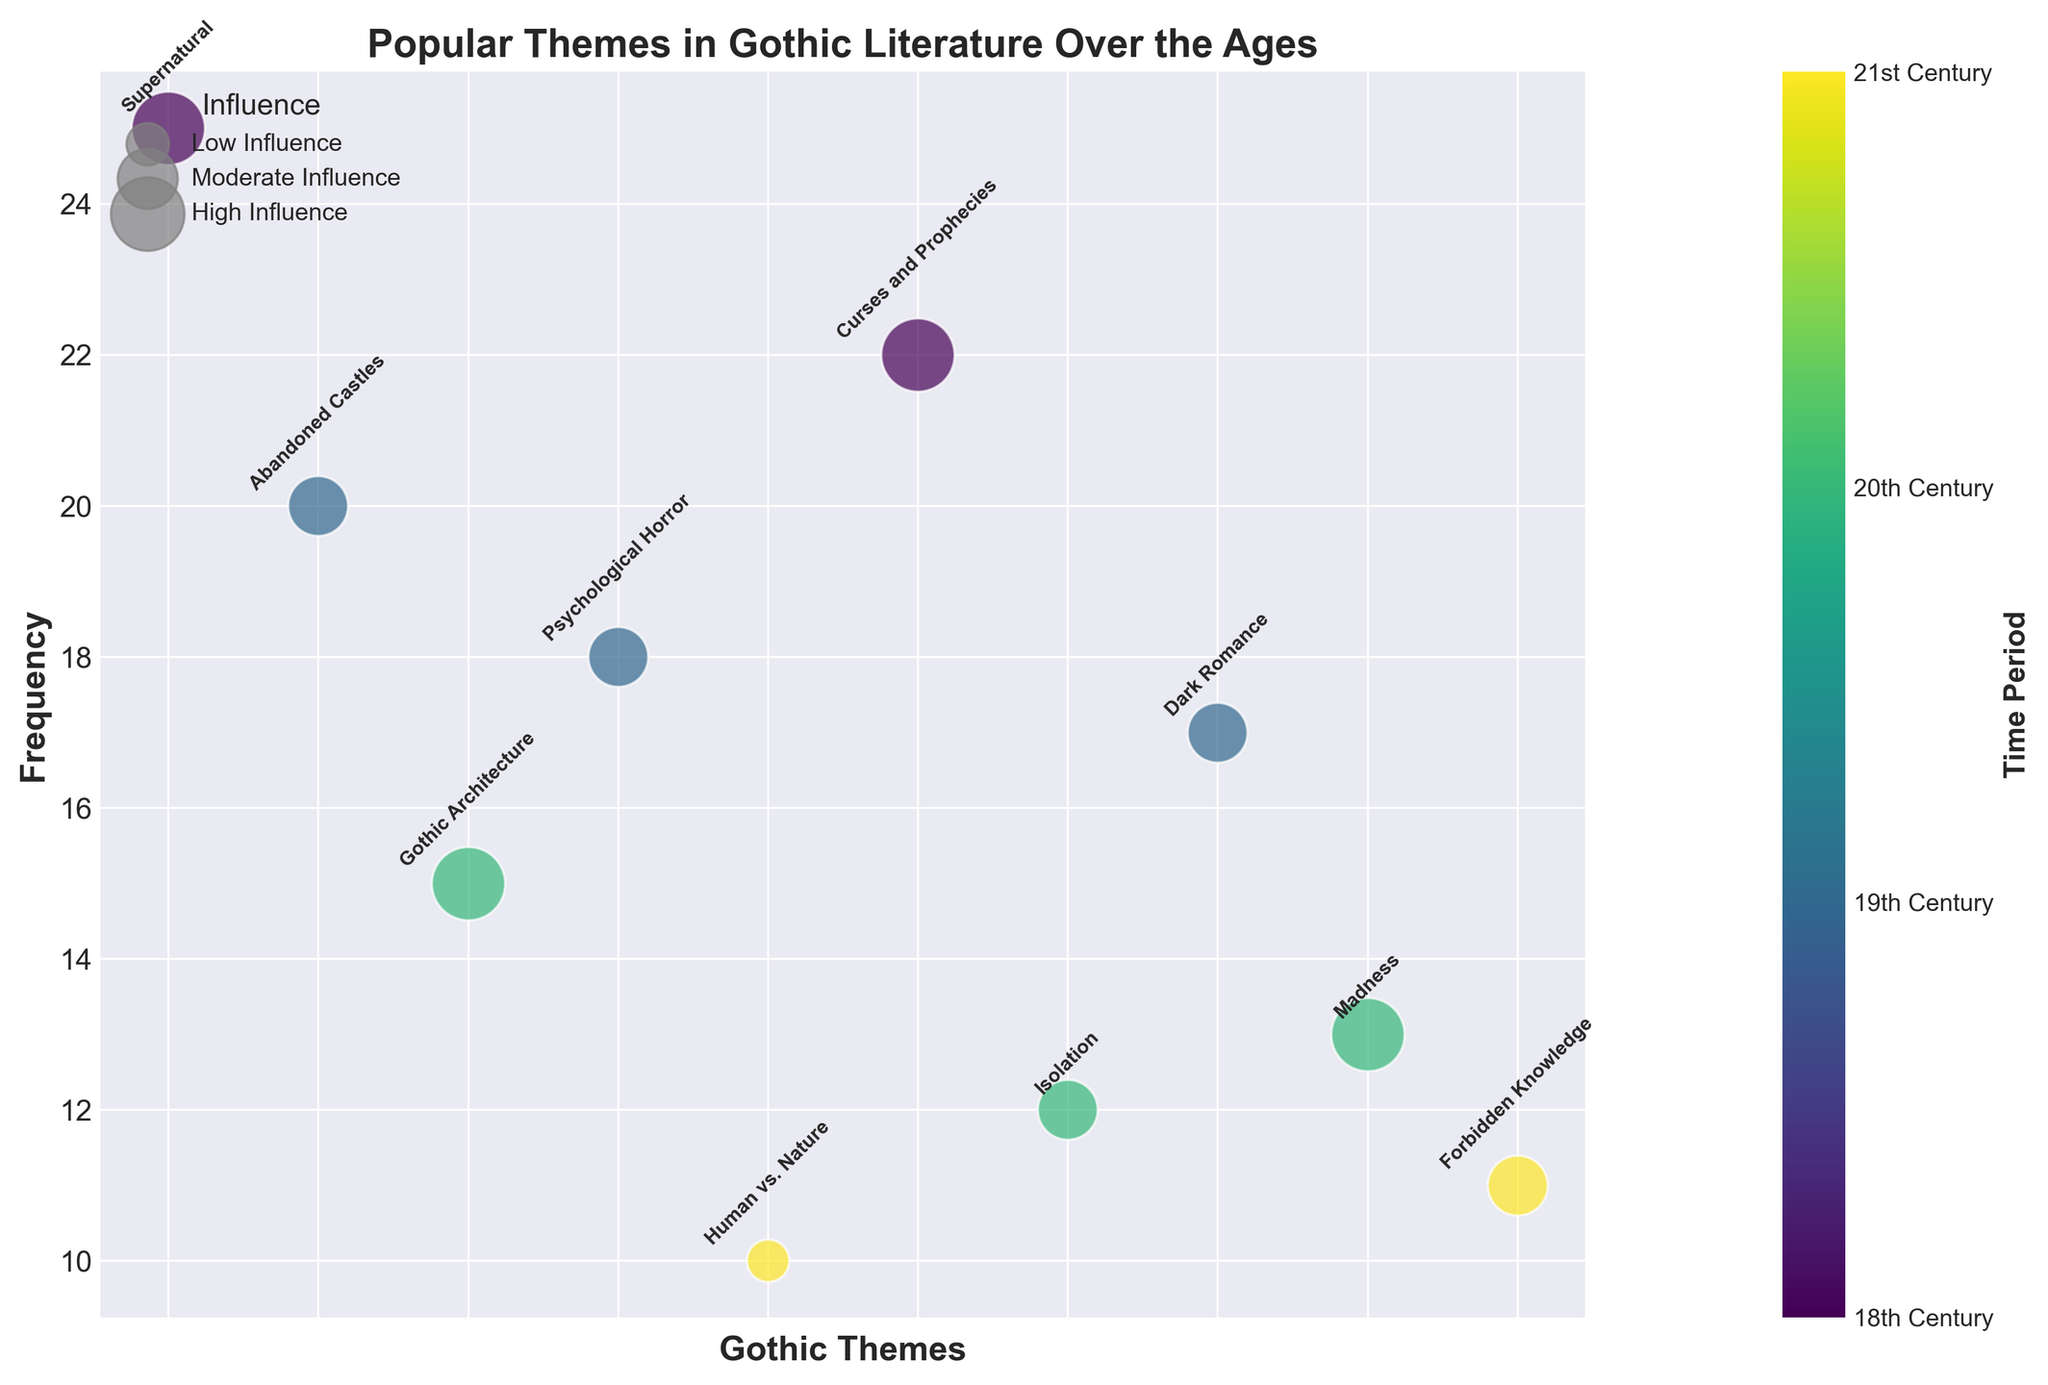Which theme has the highest frequency in the 18th Century? The 18th Century has two themes: Supernatural with a frequency of 25, and Curses and Prophecies with a frequency of 22. The highest frequency is 25 for Supernatural.
Answer: Supernatural What is the total frequency of themes in the 19th Century? The 19th Century includes three themes: Abandoned Castles with a frequency of 20, Psychological Horror with a frequency of 18, and Dark Romance with a frequency of 17. Summing these gives 20 + 18 + 17 = 55.
Answer: 55 Which period has themes with the smallest bubbles, and what does this imply about their influence? In the figure, the smallest bubbles represent low influence. The 21st Century contains the themes with the smallest bubbles (Human vs. Nature and Forbidden Knowledge).
Answer: 21st Century, Low Influence Which theme from the 20th Century has a higher frequency, Isolation or Madness? From the 20th Century, the frequency of Isolation is 12, and the frequency of Madness is 13. Comparison shows that Madness has a higher frequency.
Answer: Madness How many themes are categorized under "High" influence? Name them. Identifying the bubbles with the largest size indicates high influence. High influence themes are Supernatural, Gothic Architecture, Curses and Prophecies, and Madness. Counting these themes, there are 4.
Answer: 4 themes: Supernatural, Gothic Architecture, Curses and Prophecies, Madness What is the average frequency of themes with "Moderate" influence? The themes with moderate influence and their frequencies are Abandoned Castles (20), Psychological Horror (18), Dark Romance (17), Isolation (12), and Forbidden Knowledge (11). The sum is 20 + 18 + 17 + 12 + 11 = 78. Divided by the number of themes (5), the average frequency is 78 / 5 = 15.6.
Answer: 15.6 Which period has the most diverse collection of themes based on their frequency range? By comparing the frequency ranges within each period: 
- 18th Century: 25 to 22 (range 3)
- 19th Century: 20 to 17 (range 3)
- 20th Century: 15 to 12 (range 3)
- 21st Century: 11 to 10 (range 1)
All periods except the 21st Century have the same frequency range of 3.
Answer: 18th, 19th, and 20th Century Which theme has the smallest frequency in the entire dataset, and from which period is it? Reviewing the frequency values, the smallest frequency across all themes is 10 for the theme Human vs. Nature from the 21st Century.
Answer: Human vs. Nature, 21st Century What is the combined influence of themes from the 19th Century? (Consider the number of themes and their influence types) In the 19th Century, the themes are Abandoned Castles, Psychological Horror, and Dark Romance all with moderate influence. Each theme has an influence size of 600; combining these for three themes gives 600 * 3 = 1800.
Answer: 1800 